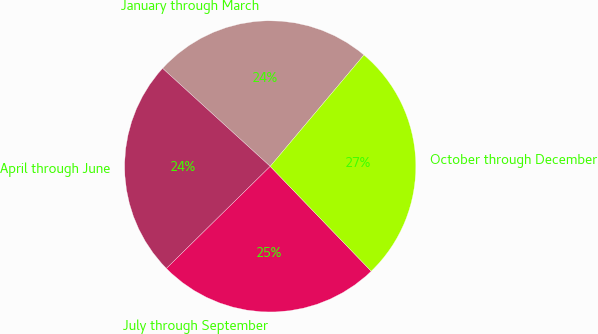<chart> <loc_0><loc_0><loc_500><loc_500><pie_chart><fcel>January through March<fcel>April through June<fcel>July through September<fcel>October through December<nl><fcel>24.38%<fcel>24.12%<fcel>24.84%<fcel>26.66%<nl></chart> 